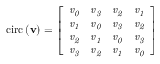Convert formula to latex. <formula><loc_0><loc_0><loc_500><loc_500>c i r c \left ( v \right ) = \left [ \begin{array} { l l l l } { v _ { 0 } } & { v _ { 3 } } & { v _ { 2 } } & { v _ { 1 } } \\ { v _ { 1 } } & { v _ { 0 } } & { v _ { 3 } } & { v _ { 2 } } \\ { v _ { 2 } } & { v _ { 1 } } & { v _ { 0 } } & { v _ { 3 } } \\ { v _ { 3 } } & { v _ { 2 } } & { v _ { 1 } } & { v _ { 0 } } \end{array} \right ]</formula> 